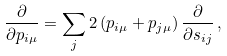Convert formula to latex. <formula><loc_0><loc_0><loc_500><loc_500>\frac { \partial } { \partial p _ { i \mu } } = \sum _ { j } 2 \left ( p _ { i \mu } + p _ { j \mu } \right ) \frac { \partial } { \partial s _ { i j } } \, ,</formula> 